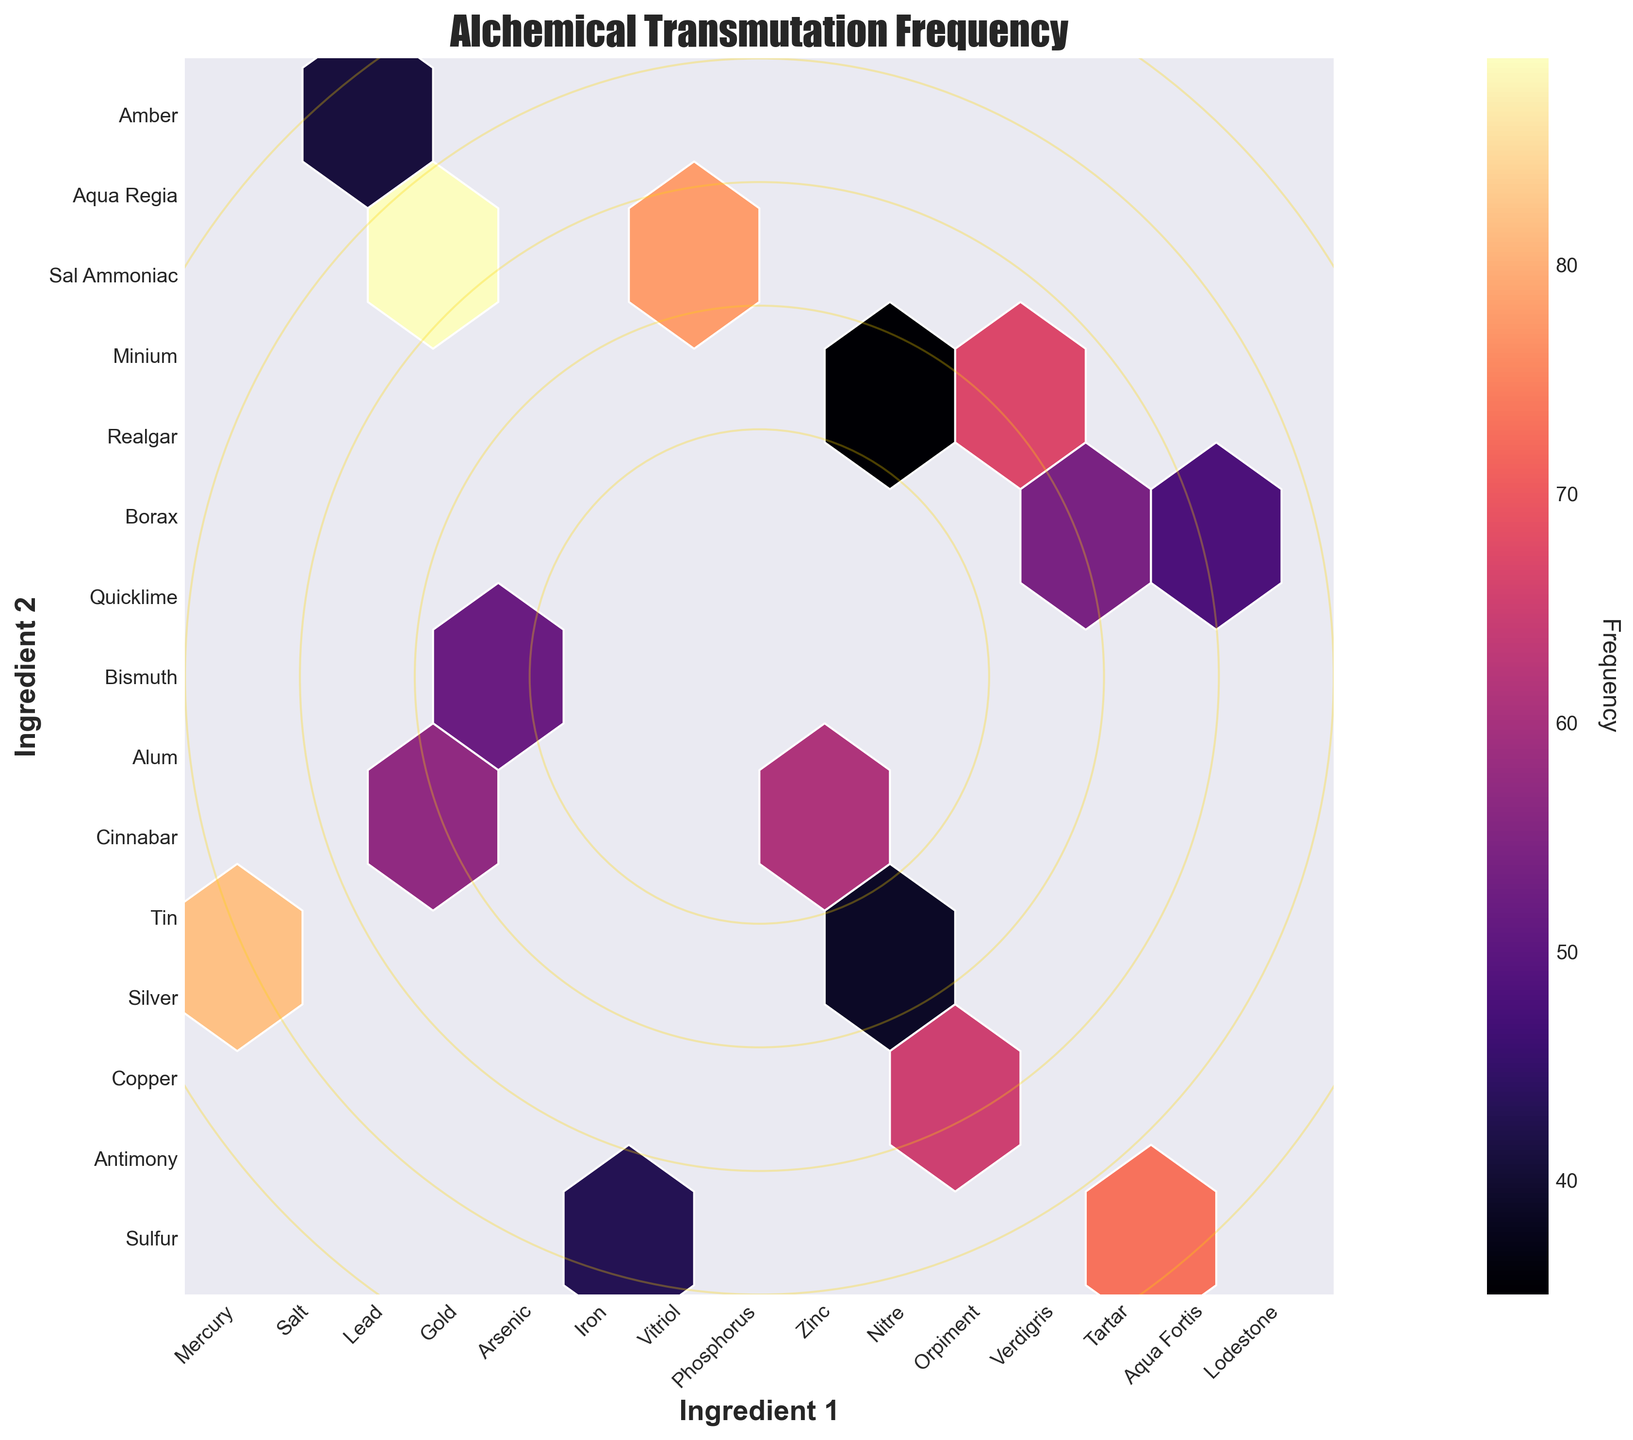What is the title of the plot? The title can be found at the top of the figure. It typically describes the content or purpose of the plot. Here, it's styled elaborately.
Answer: Alchemical Transmutation Frequency Which axis represents Ingredient 1? The axes are labeled, and Ingredient 1 is labeled on the horizontal (x) axis. The label is positioned below the axis.
Answer: Horizontal axis How is the frequency of transmutations visualized in this plot? The hexagonal bins are colored with various shades. The color intensity correlates with the frequency; darker colors signify higher frequencies.
Answer: Through color intensity in hexagonal bins How many unique ingredients are represented on the vertical (y) axis? Examine the labels on the vertical axis, each label corresponds to a unique ingredient.
Answer: 15 Which ingredient combination has the highest frequency of transmutations in the plot? By observing the darkest hexagon (with the highest frequency), one can identify Gold and Silver as the ingredients involved.
Answer: Gold and Silver What is the color scheme used for visualizing the frequencies? The colors used in the hexagons follow a palette that ranges to darker shades; it's derived from the 'magma' colormap.
Answer: Magma Is there any combination that has a frequency close to 50? If so, which one(s)? By inspecting lighter-colored hexagons, the ones closer to an average shade around the middle of the color scale can be found. Lead-Copper and Verdigris-Minium combinations are examples.
Answer: Lead-Copper, Verdigris-Minium What is the combined frequency of transmutations for Mercury-Sulfur and Aqua Fortis-Aqua Regia? Sum up the frequencies of each of the given pairs: 78 (Mercury-Sulfur) + 82 (Aqua Fortis-Aqua Regia) = 160.
Answer: 160 Would the combination of Vitriol and Alum be considered highly frequent based on the color? Given the dark shade of their corresponding hexagon, it suggests a relatively high frequency.
Answer: Yes Comparing Phosphorus-Bismuth and Lodestone-Amber, which one has a lower frequency? Observe the color of both hexagons; the lighter shade identifies the lower frequency, which is for Phosphorus-Bismuth.
Answer: Phosphorus-Bismuth 